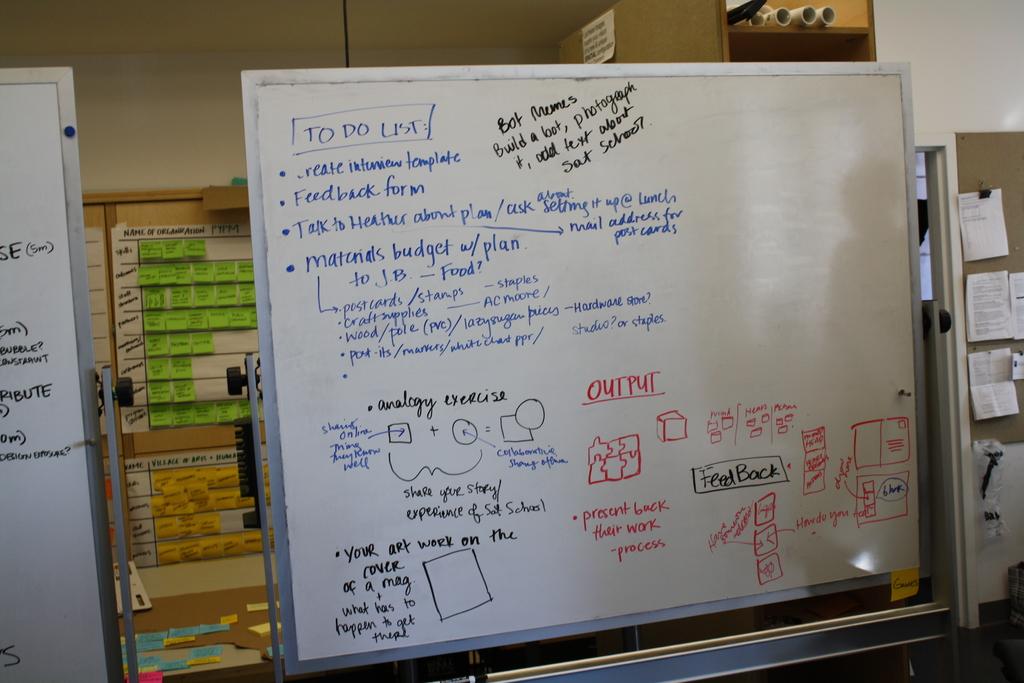What kind of form do they need to do?
Your answer should be very brief. Feedback. 